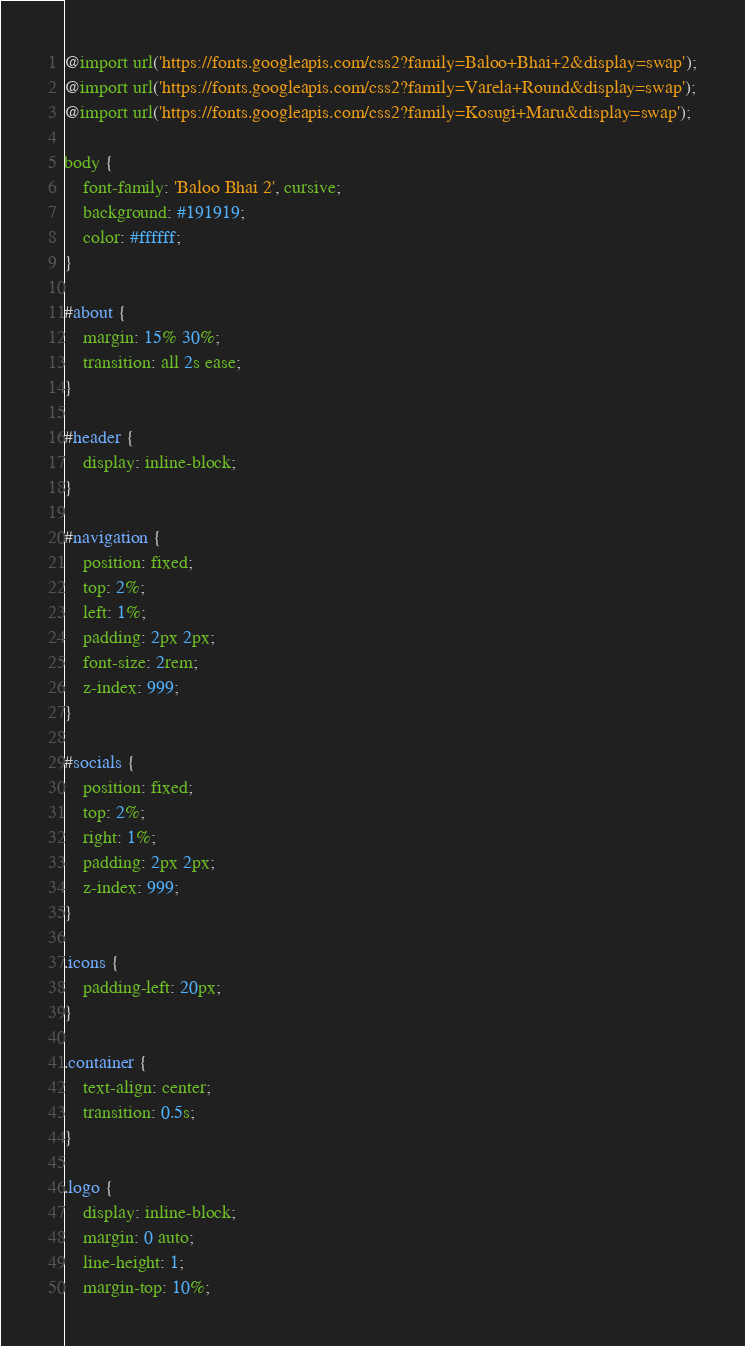<code> <loc_0><loc_0><loc_500><loc_500><_CSS_>@import url('https://fonts.googleapis.com/css2?family=Baloo+Bhai+2&display=swap');
@import url('https://fonts.googleapis.com/css2?family=Varela+Round&display=swap');
@import url('https://fonts.googleapis.com/css2?family=Kosugi+Maru&display=swap');

body {
    font-family: 'Baloo Bhai 2', cursive;
    background: #191919;
    color: #ffffff;
}

#about {
    margin: 15% 30%;
    transition: all 2s ease;
}

#header {
    display: inline-block;
}

#navigation {
    position: fixed;
    top: 2%;
    left: 1%;
    padding: 2px 2px;
    font-size: 2rem;
    z-index: 999;
}

#socials {
    position: fixed;
    top: 2%;
    right: 1%;
    padding: 2px 2px;
    z-index: 999;
}

.icons {
    padding-left: 20px;
}

.container {
    text-align: center;
    transition: 0.5s;
}

.logo {
    display: inline-block;
    margin: 0 auto;
    line-height: 1;
    margin-top: 10%;</code> 